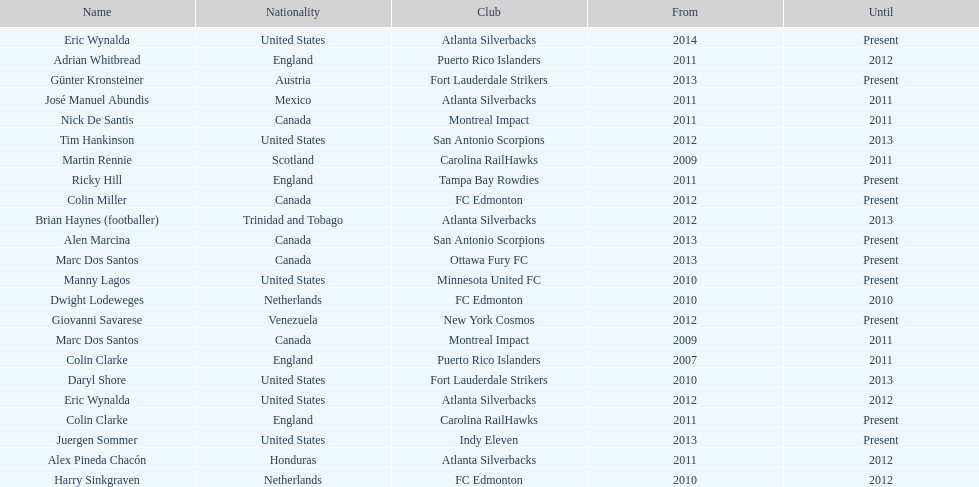How many total coaches on the list are from canada? 5. 